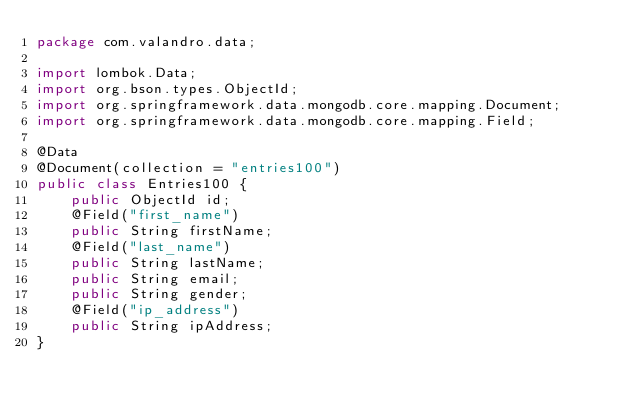<code> <loc_0><loc_0><loc_500><loc_500><_Java_>package com.valandro.data;

import lombok.Data;
import org.bson.types.ObjectId;
import org.springframework.data.mongodb.core.mapping.Document;
import org.springframework.data.mongodb.core.mapping.Field;

@Data
@Document(collection = "entries100")
public class Entries100 {
    public ObjectId id;
    @Field("first_name")
    public String firstName;
    @Field("last_name")
    public String lastName;
    public String email;
    public String gender;
    @Field("ip_address")
    public String ipAddress;
}
</code> 